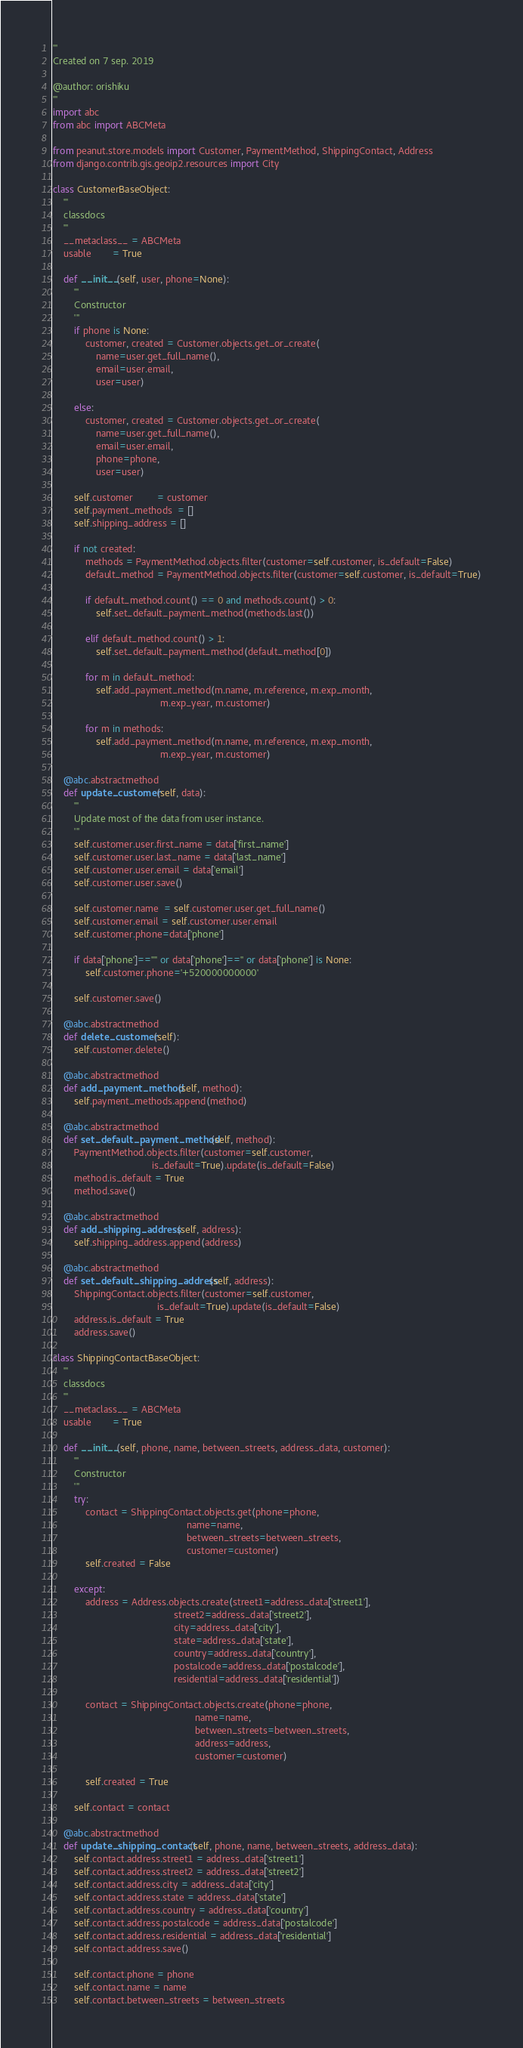Convert code to text. <code><loc_0><loc_0><loc_500><loc_500><_Python_>'''
Created on 7 sep. 2019

@author: orishiku
'''
import abc
from abc import ABCMeta

from peanut.store.models import Customer, PaymentMethod, ShippingContact, Address
from django.contrib.gis.geoip2.resources import City

class CustomerBaseObject:
    '''
    classdocs
    '''
    __metaclass__ = ABCMeta
    usable        = True
    
    def __init__(self, user, phone=None):
        '''
        Constructor 
        '''
        if phone is None:
            customer, created = Customer.objects.get_or_create(
                name=user.get_full_name(),
                email=user.email,
                user=user)

        else:
            customer, created = Customer.objects.get_or_create(
                name=user.get_full_name(),
                email=user.email,
                phone=phone,
                user=user)

        self.customer         = customer
        self.payment_methods  = []
        self.shipping_address = []

        if not created:
            methods = PaymentMethod.objects.filter(customer=self.customer, is_default=False)
            default_method = PaymentMethod.objects.filter(customer=self.customer, is_default=True)

            if default_method.count() == 0 and methods.count() > 0:
                self.set_default_payment_method(methods.last())

            elif default_method.count() > 1:
                self.set_default_payment_method(default_method[0])

            for m in default_method:
                self.add_payment_method(m.name, m.reference, m.exp_month,
                                        m.exp_year, m.customer)

            for m in methods:
                self.add_payment_method(m.name, m.reference, m.exp_month,
                                        m.exp_year, m.customer)

    @abc.abstractmethod
    def update_customer(self, data):
        '''
        Update most of the data from user instance.
        '''
        self.customer.user.first_name = data['first_name']
        self.customer.user.last_name = data['last_name']
        self.customer.user.email = data['email']
        self.customer.user.save()
        
        self.customer.name  = self.customer.user.get_full_name()
        self.customer.email = self.customer.user.email
        self.customer.phone=data['phone']
        
        if data['phone']=="" or data['phone']=='' or data['phone'] is None:
            self.customer.phone='+520000000000'
            
        self.customer.save()

    @abc.abstractmethod
    def delete_customer(self):
        self.customer.delete()
    
    @abc.abstractmethod
    def add_payment_method(self, method):
        self.payment_methods.append(method)

    @abc.abstractmethod
    def set_default_payment_method(self, method):
        PaymentMethod.objects.filter(customer=self.customer,
                                     is_default=True).update(is_default=False)
        method.is_default = True
        method.save()
        
    @abc.abstractmethod
    def add_shipping_address(self, address):
        self.shipping_address.append(address)

    @abc.abstractmethod
    def set_default_shipping_address(self, address):
        ShippingContact.objects.filter(customer=self.customer,
                                       is_default=True).update(is_default=False)
        address.is_default = True
        address.save()
        
class ShippingContactBaseObject:
    '''
    classdocs
    '''
    __metaclass__ = ABCMeta
    usable        = True
    
    def __init__(self, phone, name, between_streets, address_data, customer):
        '''
        Constructor
        '''
        try:
            contact = ShippingContact.objects.get(phone=phone,
                                                  name=name,
                                                  between_streets=between_streets,
                                                  customer=customer)
            self.created = False

        except:
            address = Address.objects.create(street1=address_data['street1'],
                                             street2=address_data['street2'],
                                             city=address_data['city'],
                                             state=address_data['state'],
                                             country=address_data['country'],
                                             postalcode=address_data['postalcode'],
                                             residential=address_data['residential'])

            contact = ShippingContact.objects.create(phone=phone,
                                                     name=name,
                                                     between_streets=between_streets,
                                                     address=address,
                                                     customer=customer)

            self.created = True

        self.contact = contact
    
    @abc.abstractmethod
    def update_shipping_contact(self, phone, name, between_streets, address_data):
        self.contact.address.street1 = address_data['street1']
        self.contact.address.street2 = address_data['street2']
        self.contact.address.city = address_data['city']
        self.contact.address.state = address_data['state']
        self.contact.address.country = address_data['country']
        self.contact.address.postalcode = address_data['postalcode']
        self.contact.address.residential = address_data['residential']
        self.contact.address.save()
        
        self.contact.phone = phone
        self.contact.name = name
        self.contact.between_streets = between_streets</code> 